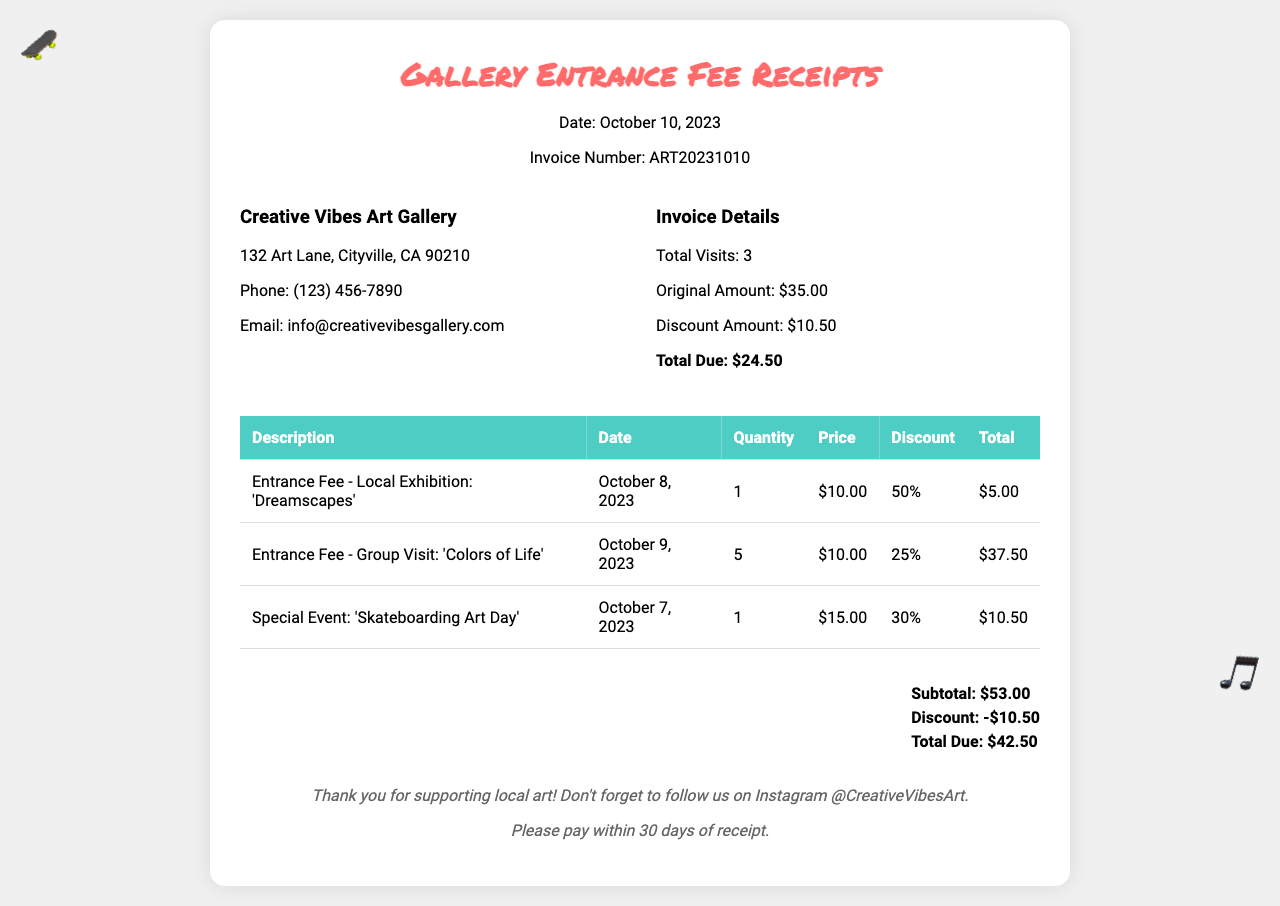what is the date of the invoice? The date is listed under the header section of the invoice.
Answer: October 10, 2023 how many total visits are recorded? The total number of visits is indicated in the invoice details section.
Answer: 3 what is the original amount before discounts? The original amount is included in the invoice details.
Answer: $35.00 what discount amount was applied? The discount amount appears in the invoice details section.
Answer: $10.50 what was the total due after discounts? The total due is summarized in the invoice section.
Answer: $24.50 how many people attended the 'Colors of Life' exhibition? The quantity for the 'Colors of Life' exhibition is provided in the table of visits.
Answer: 5 what is the price for the 'Skateboarding Art Day' event? The price for the specific event is listed in the table under the price column.
Answer: $15.00 which exhibition received a 50% discount? The discount percentage for each entry is shown, and the specific exhibition with a 50% discount can be found in the table.
Answer: 'Dreamscapes' what is the subtotal before discounts? The subtotal is indicated in the summary section of the invoice.
Answer: $53.00 what is the email address for Creative Vibes Art Gallery? The email is listed under the gallery information section.
Answer: info@creativevibesgallery.com 